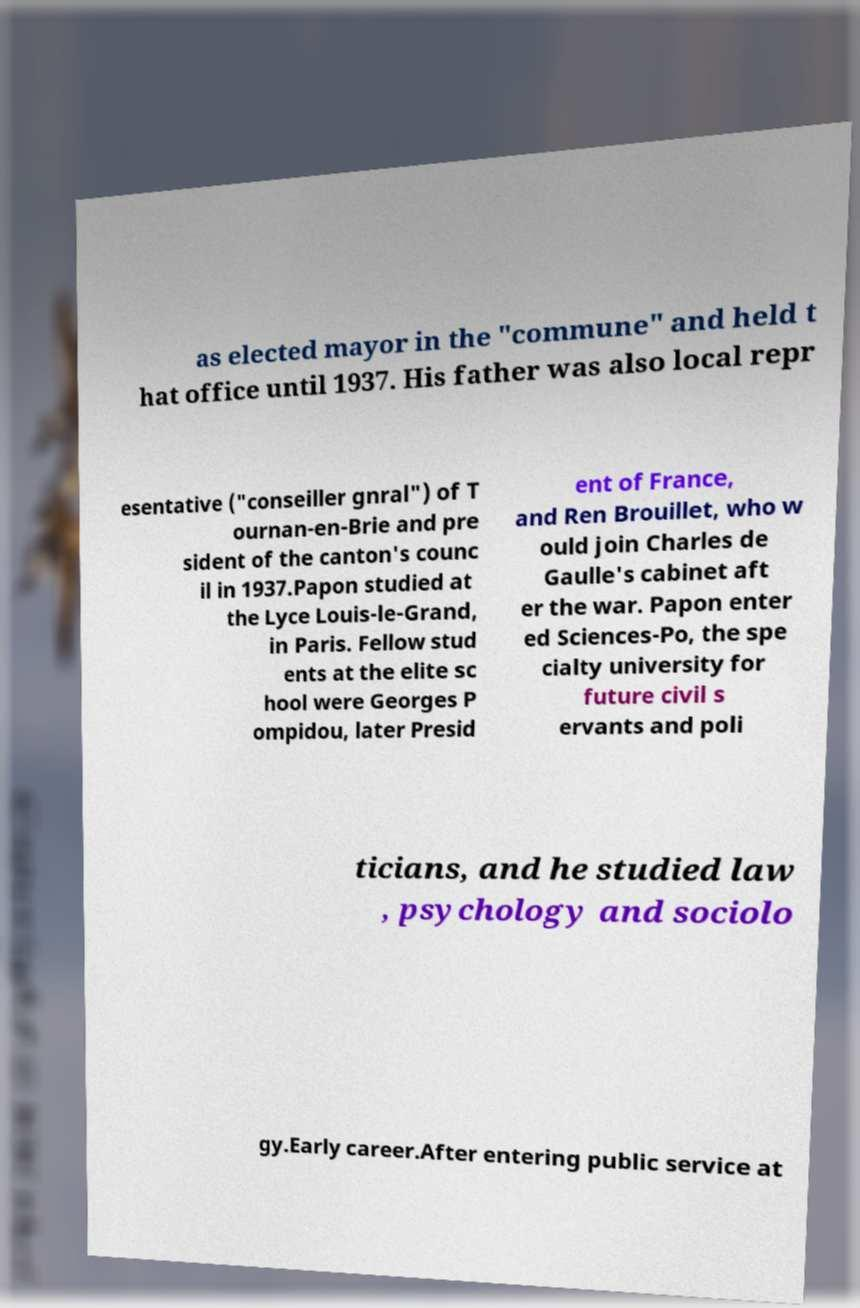Can you read and provide the text displayed in the image?This photo seems to have some interesting text. Can you extract and type it out for me? as elected mayor in the "commune" and held t hat office until 1937. His father was also local repr esentative ("conseiller gnral") of T ournan-en-Brie and pre sident of the canton's counc il in 1937.Papon studied at the Lyce Louis-le-Grand, in Paris. Fellow stud ents at the elite sc hool were Georges P ompidou, later Presid ent of France, and Ren Brouillet, who w ould join Charles de Gaulle's cabinet aft er the war. Papon enter ed Sciences-Po, the spe cialty university for future civil s ervants and poli ticians, and he studied law , psychology and sociolo gy.Early career.After entering public service at 